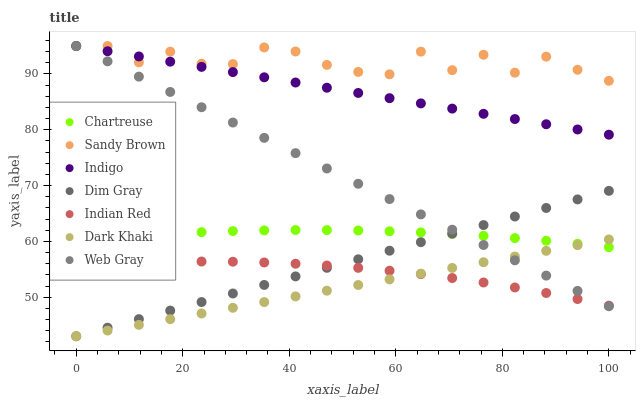Does Dark Khaki have the minimum area under the curve?
Answer yes or no. Yes. Does Sandy Brown have the maximum area under the curve?
Answer yes or no. Yes. Does Indigo have the minimum area under the curve?
Answer yes or no. No. Does Indigo have the maximum area under the curve?
Answer yes or no. No. Is Dark Khaki the smoothest?
Answer yes or no. Yes. Is Sandy Brown the roughest?
Answer yes or no. Yes. Is Indigo the smoothest?
Answer yes or no. No. Is Indigo the roughest?
Answer yes or no. No. Does Dim Gray have the lowest value?
Answer yes or no. Yes. Does Indigo have the lowest value?
Answer yes or no. No. Does Sandy Brown have the highest value?
Answer yes or no. Yes. Does Dark Khaki have the highest value?
Answer yes or no. No. Is Dark Khaki less than Sandy Brown?
Answer yes or no. Yes. Is Indigo greater than Indian Red?
Answer yes or no. Yes. Does Dark Khaki intersect Dim Gray?
Answer yes or no. Yes. Is Dark Khaki less than Dim Gray?
Answer yes or no. No. Is Dark Khaki greater than Dim Gray?
Answer yes or no. No. Does Dark Khaki intersect Sandy Brown?
Answer yes or no. No. 